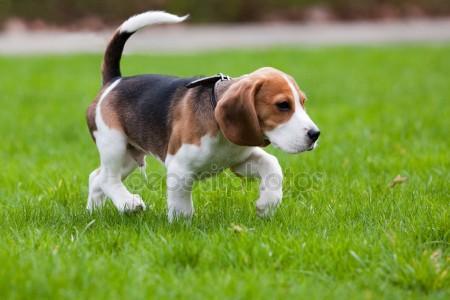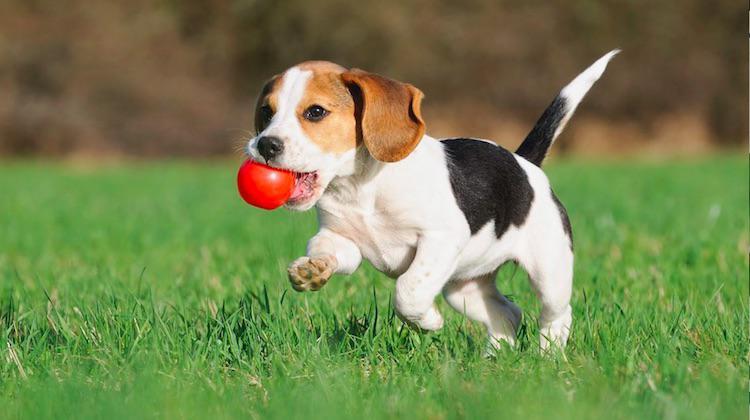The first image is the image on the left, the second image is the image on the right. Considering the images on both sides, is "The puppy in the right image is bounding across the grass." valid? Answer yes or no. Yes. 